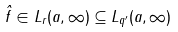<formula> <loc_0><loc_0><loc_500><loc_500>\hat { f } \in L _ { r } ( a , \infty ) \subseteq L _ { q ^ { \prime } } ( a , \infty )</formula> 